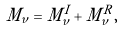<formula> <loc_0><loc_0><loc_500><loc_500>M _ { \nu } = M _ { \nu } ^ { I } + M _ { \nu } ^ { R } ,</formula> 